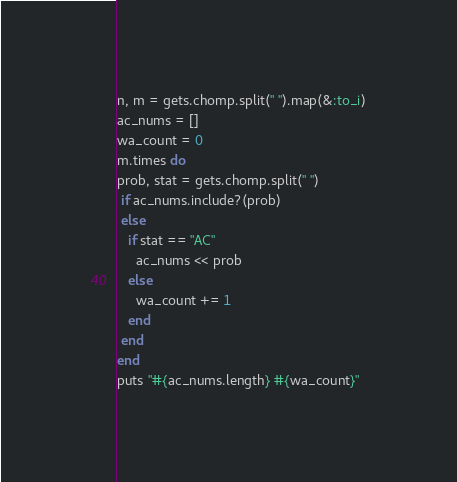Convert code to text. <code><loc_0><loc_0><loc_500><loc_500><_Ruby_>n, m = gets.chomp.split(" ").map(&:to_i)
ac_nums = []
wa_count = 0
m.times do
prob, stat = gets.chomp.split(" ")
 if ac_nums.include?(prob)
 else
   if stat == "AC"
     ac_nums << prob
   else
     wa_count += 1
   end
 end
end
puts "#{ac_nums.length} #{wa_count}"
</code> 